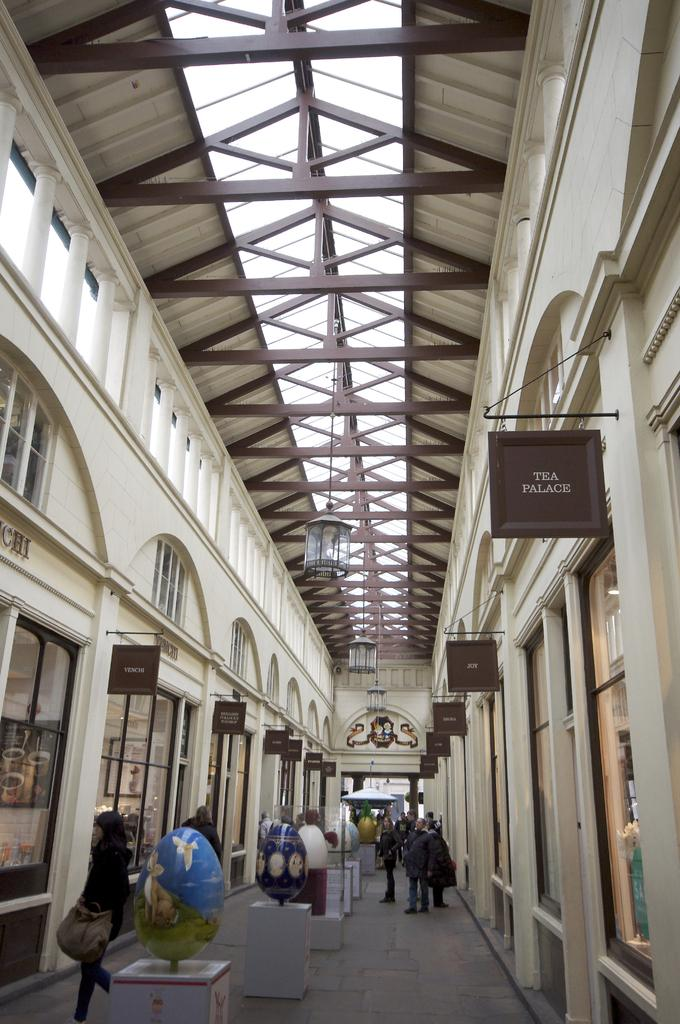How many people are in the image? There are persons standing in the image. What can be seen on the stand in the image? There is a stand with gloves in the image. What architectural features are present in the image? There are pillars and a wall in the image. What type of signage is visible in the image? There are name boards in the image. What is the source of light in the image? There is a lamp attached to the roof in the image. Is there any bait visible in the image? There is no bait present in the image. Is the ground covered in snow in the image? There is no snow visible in the image. 